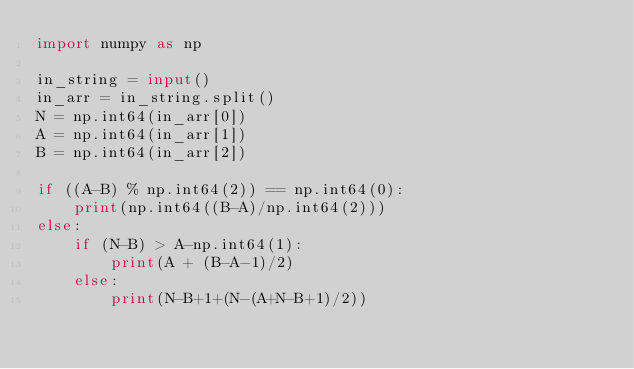<code> <loc_0><loc_0><loc_500><loc_500><_Python_>import numpy as np

in_string = input()
in_arr = in_string.split()
N = np.int64(in_arr[0])
A = np.int64(in_arr[1])
B = np.int64(in_arr[2])

if ((A-B) % np.int64(2)) == np.int64(0):
    print(np.int64((B-A)/np.int64(2)))
else:
    if (N-B) > A-np.int64(1):
        print(A + (B-A-1)/2)
    else:
        print(N-B+1+(N-(A+N-B+1)/2))</code> 